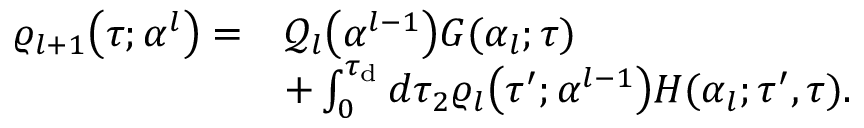<formula> <loc_0><loc_0><loc_500><loc_500>\begin{array} { r l } { \varrho _ { l + 1 } \left ( \tau ; \alpha ^ { l } \right ) = } & { \mathcal { Q } _ { l } \left ( \alpha ^ { l - 1 } \right ) G ( \alpha _ { l } ; \tau ) } \\ & { + \int _ { 0 } ^ { \tau _ { d } } d \tau _ { 2 } \varrho _ { l } \left ( \tau ^ { \prime } ; \alpha ^ { l - 1 } \right ) H ( \alpha _ { l } ; \tau ^ { \prime } , \tau ) . } \end{array}</formula> 